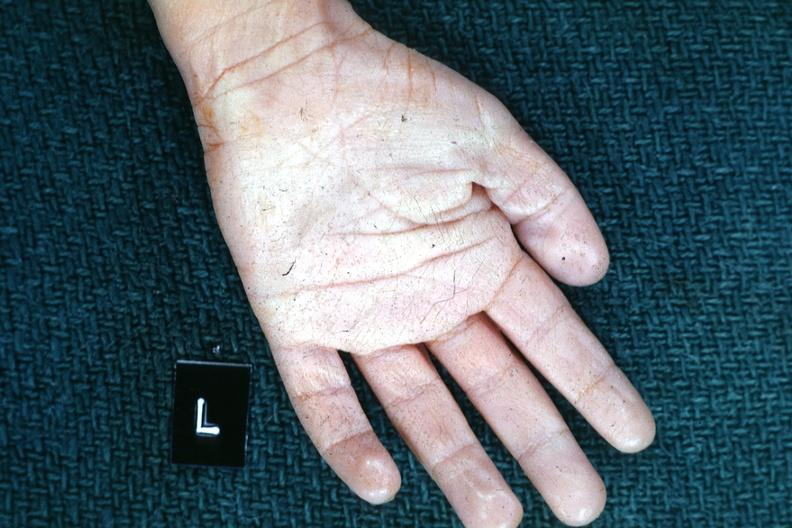s normal palmar creases present?
Answer the question using a single word or phrase. Yes 